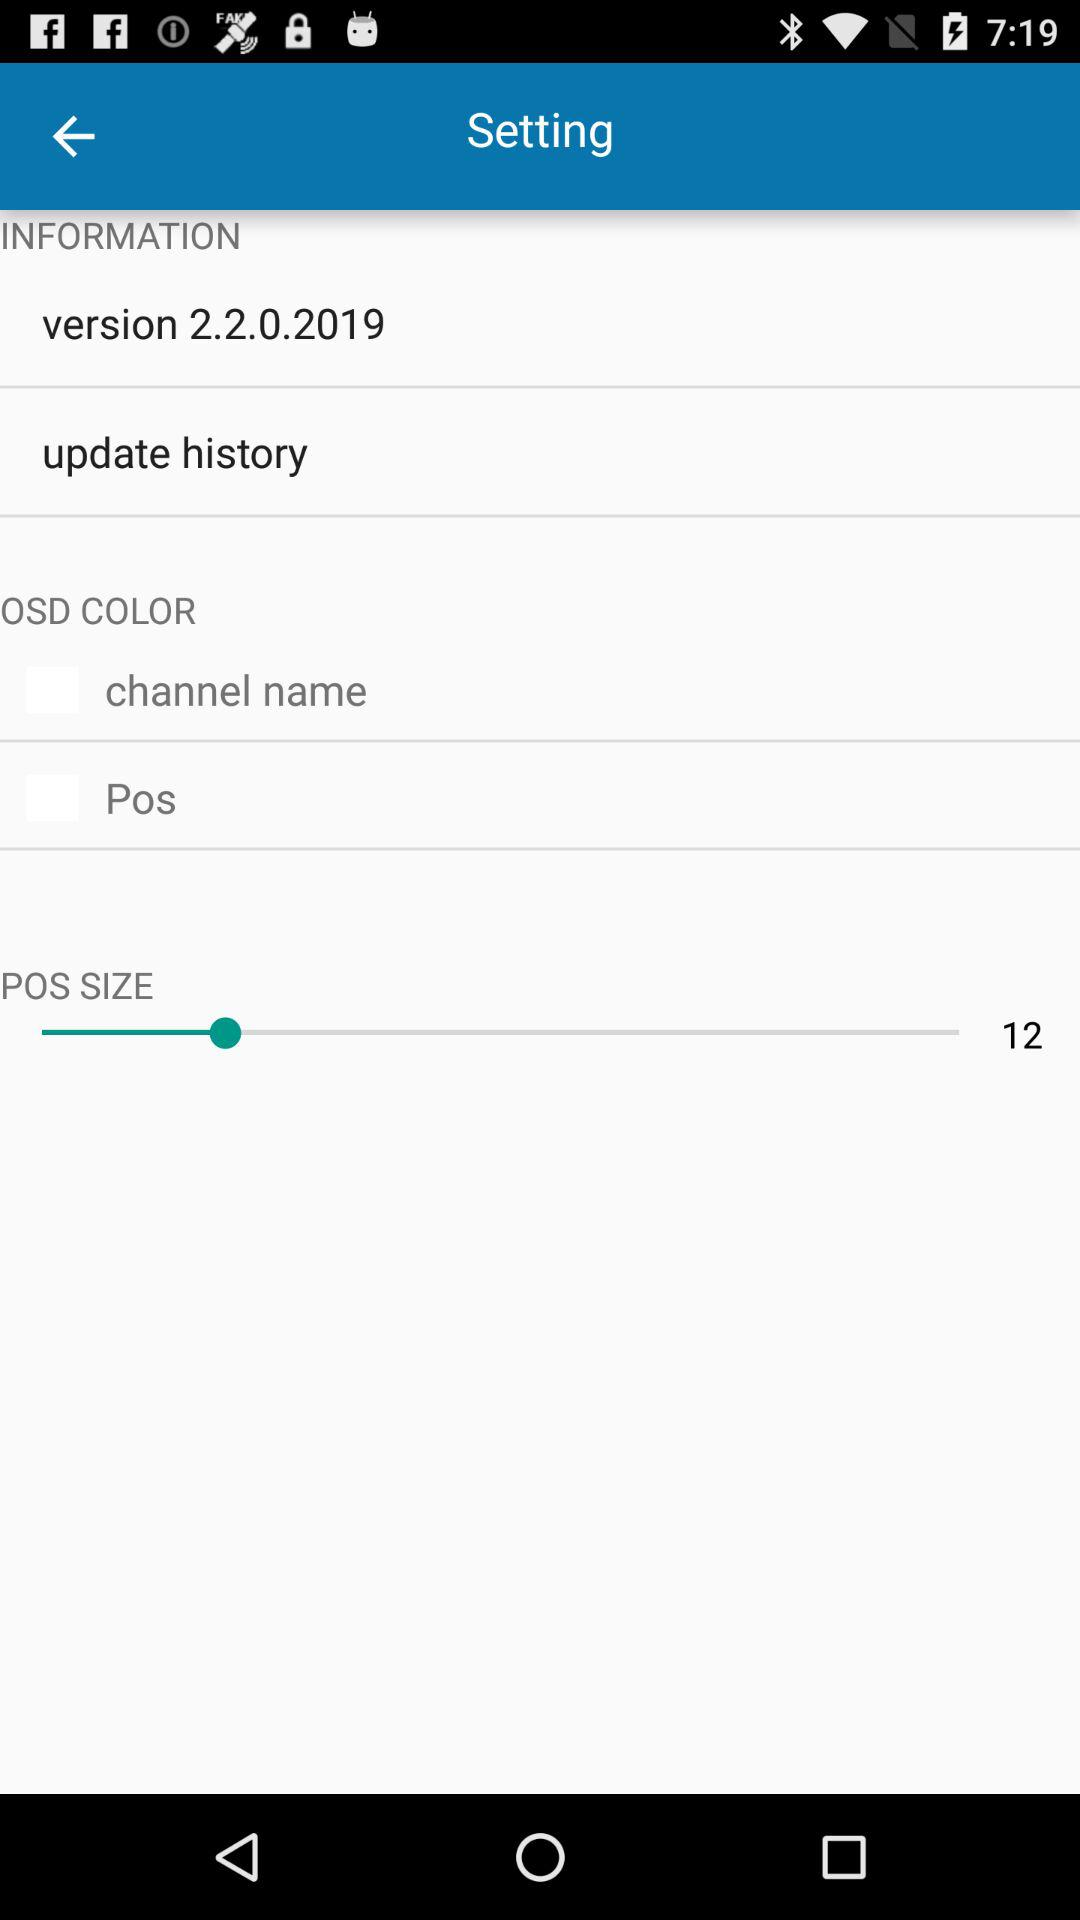What is the POS size selected? The selected POS size is 12. 